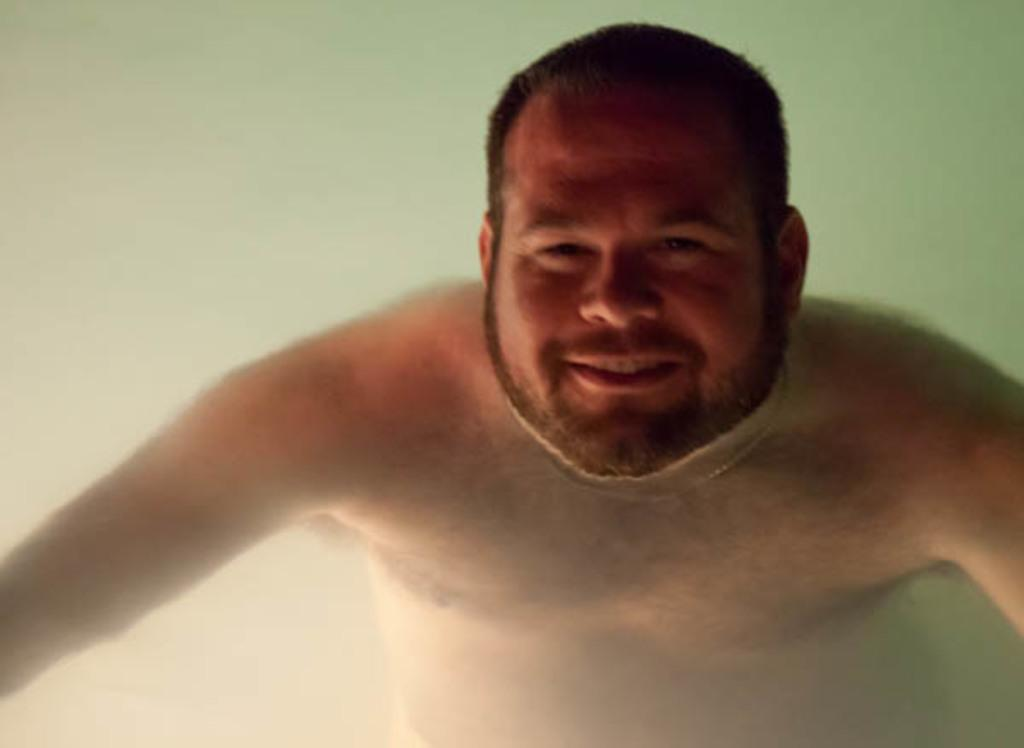Who is the main subject in the image? There is a man in the image. What is the man doing in the image? The man is swimming in the water. How does the man appear to feel while swimming? The man is smiling, which suggests he is enjoying himself. Is the man aware that he is being photographed? Yes, the man is giving a pose for the picture, indicating that he is aware of the camera. What type of snail can be seen crawling on the man's shoulder in the image? There is no snail present on the man's shoulder in the image. What advice is the coach giving to the man in the image? There is no coach present in the image, so no advice can be given. 